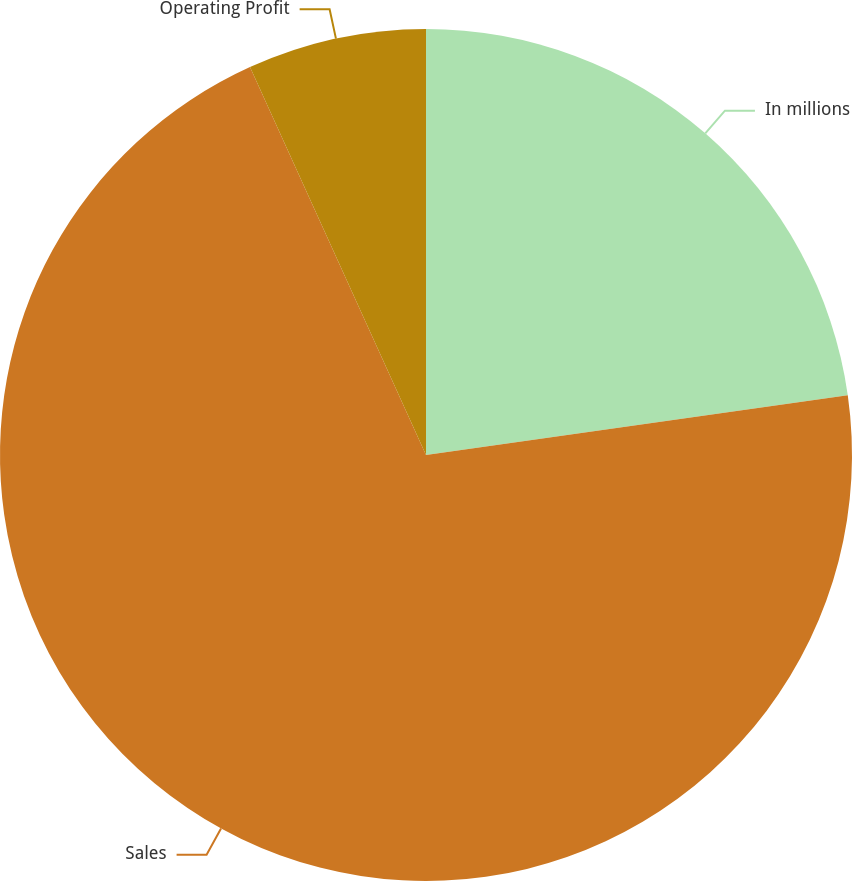Convert chart to OTSL. <chart><loc_0><loc_0><loc_500><loc_500><pie_chart><fcel>In millions<fcel>Sales<fcel>Operating Profit<nl><fcel>22.76%<fcel>70.47%<fcel>6.78%<nl></chart> 